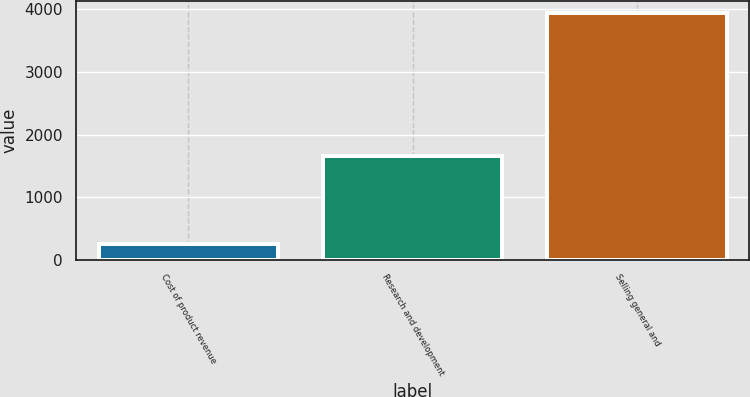Convert chart. <chart><loc_0><loc_0><loc_500><loc_500><bar_chart><fcel>Cost of product revenue<fcel>Research and development<fcel>Selling general and<nl><fcel>255<fcel>1656<fcel>3937<nl></chart> 